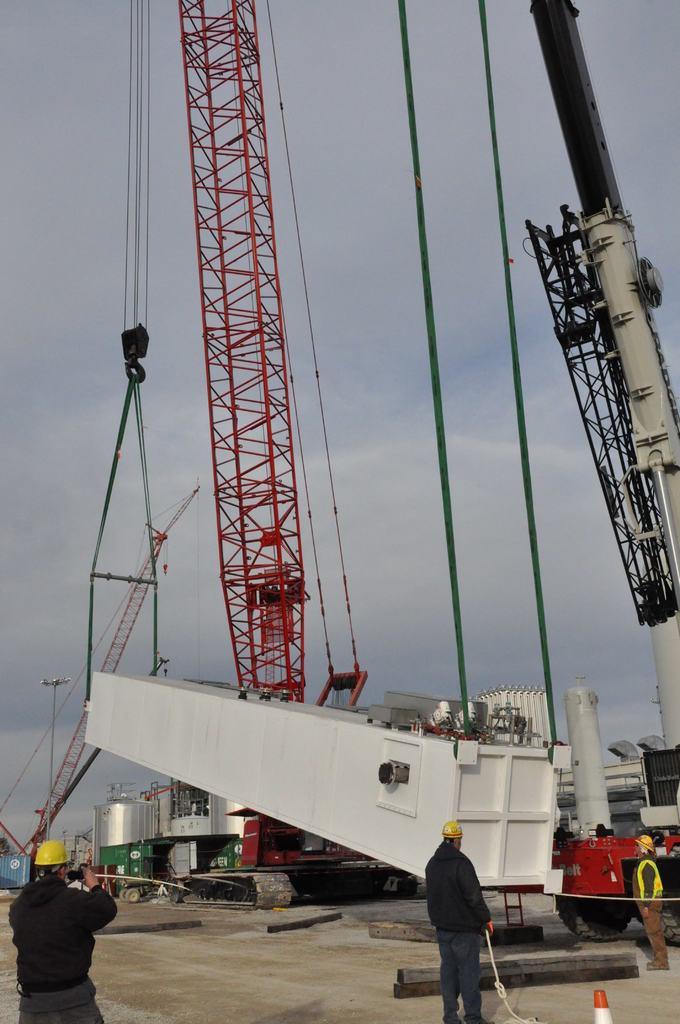In one or two sentences, can you explain what this image depicts? In this image we can see crane, ropes and tank. Bottom of the image three persons are standing. They are wearing yellow color helmet. Background of the image sky is there. 